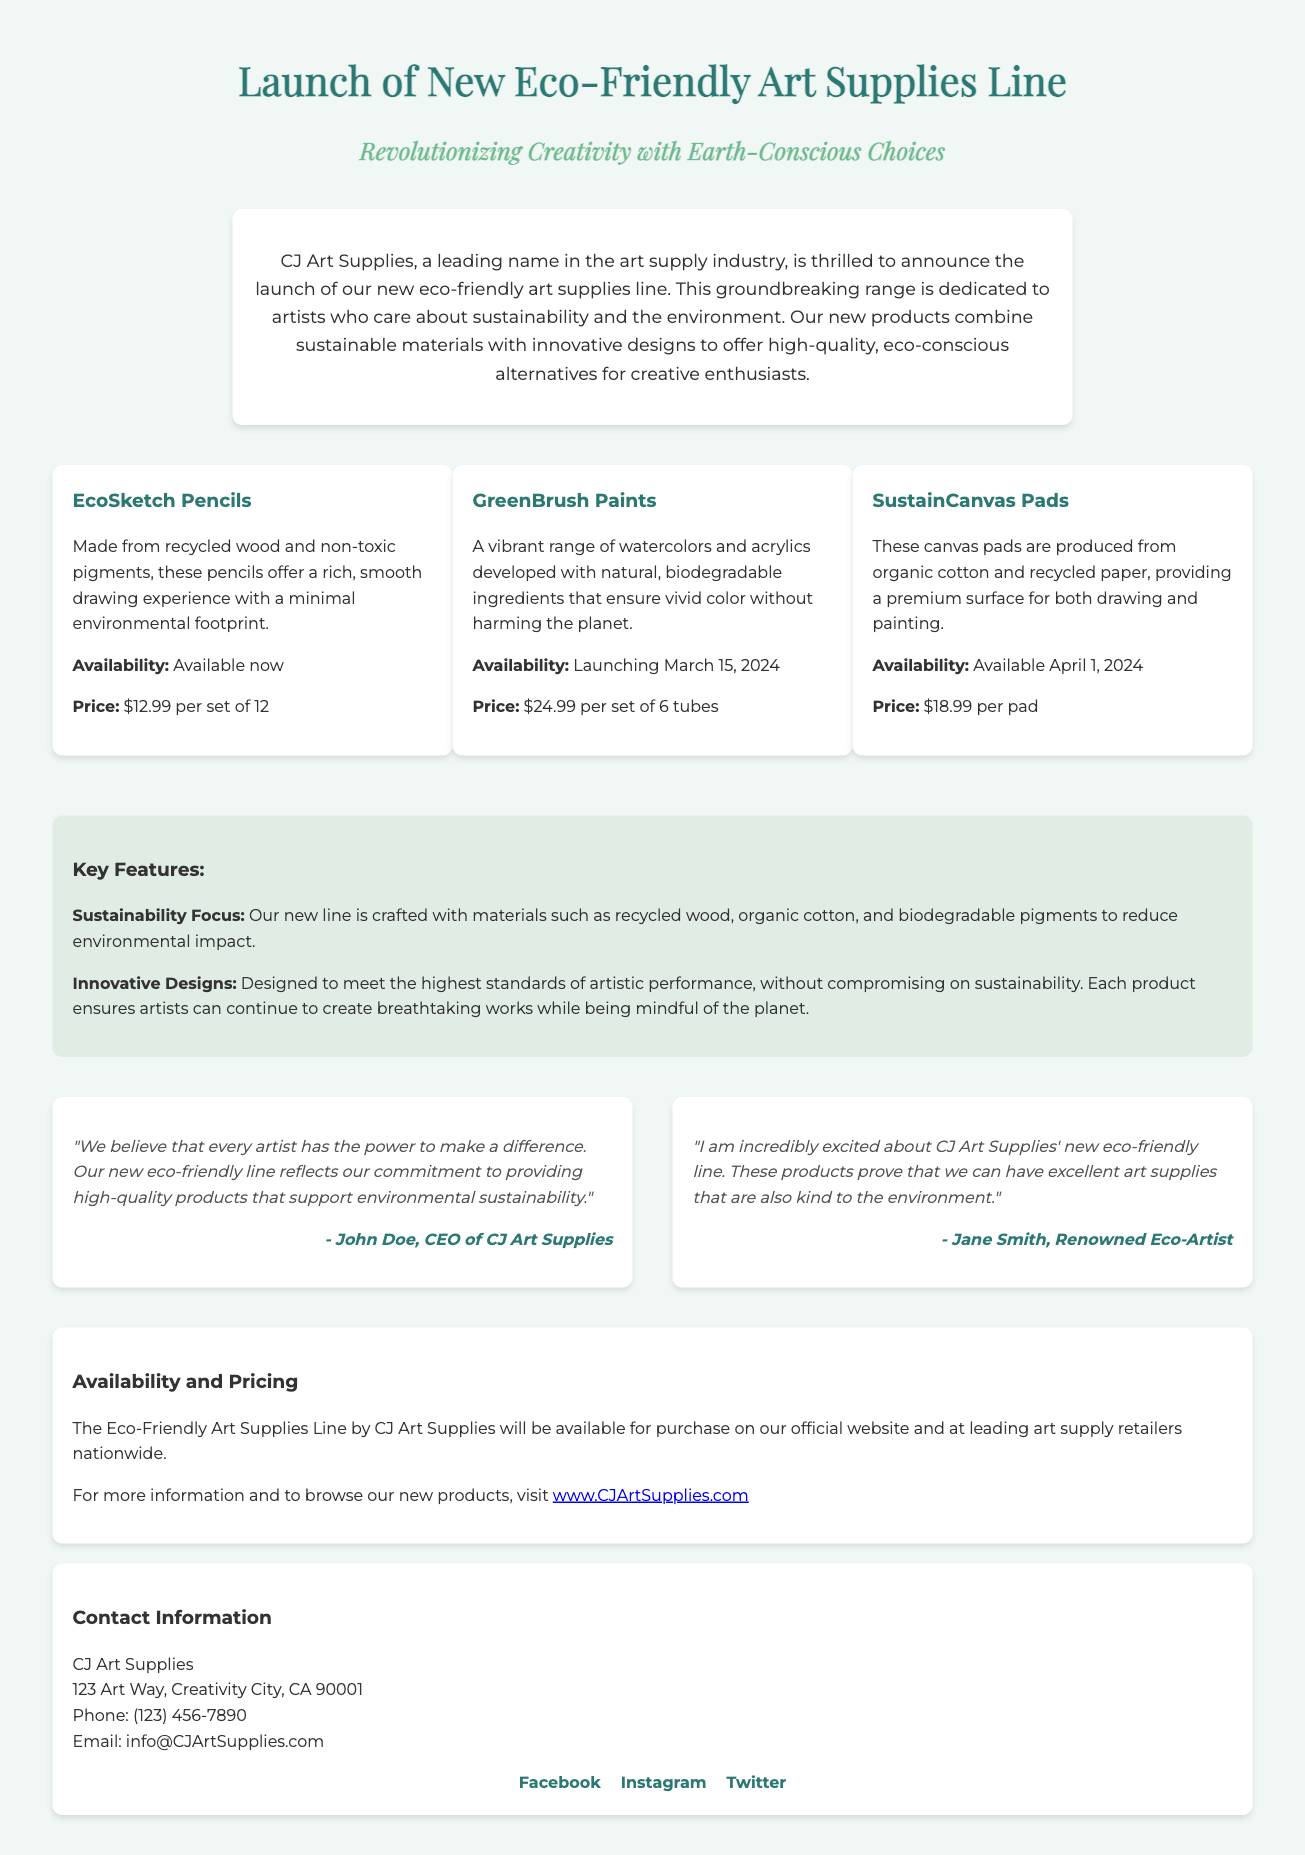What is the name of the new product line? The document states that the new product line is called the Eco-Friendly Art Supplies Line.
Answer: Eco-Friendly Art Supplies Line When will the GreenBrush Paints launch? The document mentions that the GreenBrush Paints are launching on March 15, 2024.
Answer: March 15, 2024 What materials are the EcoSketch Pencils made from? The EcoSketch Pencils are made from recycled wood and non-toxic pigments, as indicated in the document.
Answer: Recycled wood and non-toxic pigments What is the price of the SustainCanvas Pads? According to the document, the price of the SustainCanvas Pads is $18.99 per pad.
Answer: $18.99 per pad Who is the CEO of CJ Art Supplies? The document provides a quote from John Doe, who is identified as the CEO.
Answer: John Doe What is the focus of the new product line? The document states that the new line is focused on sustainability, using materials like recycled wood and organic cotton.
Answer: Sustainability What type of document is this? The structure and content indicate that this is a press release announcing new products.
Answer: Press release Where can customers find the Eco-Friendly Art Supplies for purchase? The availability section states that the new supplies will be available on the official website and at leading art supply retailers nationwide.
Answer: Official website and leading art supply retailers What is the main message conveyed by Jane Smith in her quote? Jane Smith expresses excitement about the new line proving that excellent art supplies can be environmentally friendly.
Answer: Excellent art supplies can be environmentally friendly 